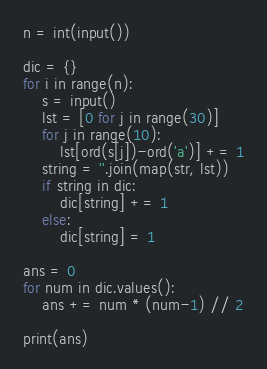<code> <loc_0><loc_0><loc_500><loc_500><_Python_>n = int(input())

dic = {}
for i in range(n):
    s = input()
    lst = [0 for j in range(30)]
    for j in range(10):
        lst[ord(s[j])-ord('a')] += 1
    string = ''.join(map(str, lst))
    if string in dic:
        dic[string] += 1
    else:
        dic[string] = 1

ans = 0
for num in dic.values():
    ans += num * (num-1) // 2

print(ans)</code> 